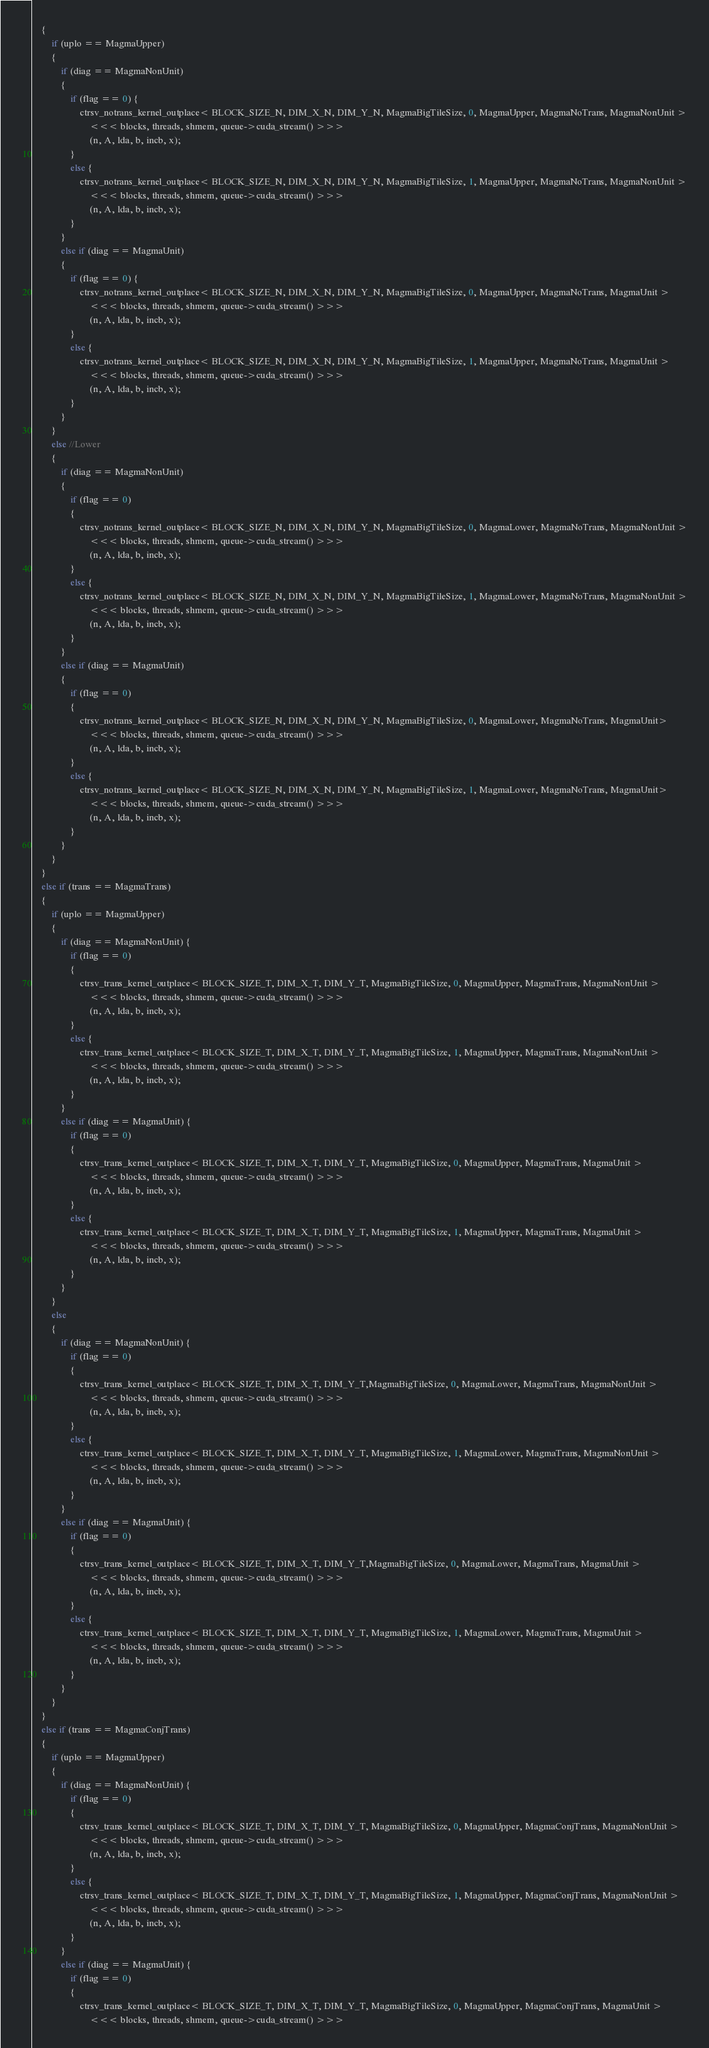Convert code to text. <code><loc_0><loc_0><loc_500><loc_500><_Cuda_>    {
        if (uplo == MagmaUpper)
        {
            if (diag == MagmaNonUnit)
            {
                if (flag == 0) {
                    ctrsv_notrans_kernel_outplace< BLOCK_SIZE_N, DIM_X_N, DIM_Y_N, MagmaBigTileSize, 0, MagmaUpper, MagmaNoTrans, MagmaNonUnit >
                        <<< blocks, threads, shmem, queue->cuda_stream() >>>
                        (n, A, lda, b, incb, x);
                }
                else {
                    ctrsv_notrans_kernel_outplace< BLOCK_SIZE_N, DIM_X_N, DIM_Y_N, MagmaBigTileSize, 1, MagmaUpper, MagmaNoTrans, MagmaNonUnit >
                        <<< blocks, threads, shmem, queue->cuda_stream() >>>
                        (n, A, lda, b, incb, x);
                }
            }
            else if (diag == MagmaUnit)
            {
                if (flag == 0) {
                    ctrsv_notrans_kernel_outplace< BLOCK_SIZE_N, DIM_X_N, DIM_Y_N, MagmaBigTileSize, 0, MagmaUpper, MagmaNoTrans, MagmaUnit >
                        <<< blocks, threads, shmem, queue->cuda_stream() >>>
                        (n, A, lda, b, incb, x);
                }
                else {
                    ctrsv_notrans_kernel_outplace< BLOCK_SIZE_N, DIM_X_N, DIM_Y_N, MagmaBigTileSize, 1, MagmaUpper, MagmaNoTrans, MagmaUnit >
                        <<< blocks, threads, shmem, queue->cuda_stream() >>>
                        (n, A, lda, b, incb, x);
                }
            }
        }
        else //Lower
        {
            if (diag == MagmaNonUnit)
            {
                if (flag == 0)
                {
                    ctrsv_notrans_kernel_outplace< BLOCK_SIZE_N, DIM_X_N, DIM_Y_N, MagmaBigTileSize, 0, MagmaLower, MagmaNoTrans, MagmaNonUnit >
                        <<< blocks, threads, shmem, queue->cuda_stream() >>>
                        (n, A, lda, b, incb, x);
                }
                else {
                    ctrsv_notrans_kernel_outplace< BLOCK_SIZE_N, DIM_X_N, DIM_Y_N, MagmaBigTileSize, 1, MagmaLower, MagmaNoTrans, MagmaNonUnit >
                        <<< blocks, threads, shmem, queue->cuda_stream() >>>
                        (n, A, lda, b, incb, x);
                }
            }
            else if (diag == MagmaUnit)
            {
                if (flag == 0)
                {
                    ctrsv_notrans_kernel_outplace< BLOCK_SIZE_N, DIM_X_N, DIM_Y_N, MagmaBigTileSize, 0, MagmaLower, MagmaNoTrans, MagmaUnit>
                        <<< blocks, threads, shmem, queue->cuda_stream() >>>
                        (n, A, lda, b, incb, x);
                }
                else {
                    ctrsv_notrans_kernel_outplace< BLOCK_SIZE_N, DIM_X_N, DIM_Y_N, MagmaBigTileSize, 1, MagmaLower, MagmaNoTrans, MagmaUnit>
                        <<< blocks, threads, shmem, queue->cuda_stream() >>>
                        (n, A, lda, b, incb, x);
                }
            }
        }
    }
    else if (trans == MagmaTrans)
    {
        if (uplo == MagmaUpper)
        {
            if (diag == MagmaNonUnit) {
                if (flag == 0)
                {
                    ctrsv_trans_kernel_outplace< BLOCK_SIZE_T, DIM_X_T, DIM_Y_T, MagmaBigTileSize, 0, MagmaUpper, MagmaTrans, MagmaNonUnit >
                        <<< blocks, threads, shmem, queue->cuda_stream() >>>
                        (n, A, lda, b, incb, x);
                }
                else {
                    ctrsv_trans_kernel_outplace< BLOCK_SIZE_T, DIM_X_T, DIM_Y_T, MagmaBigTileSize, 1, MagmaUpper, MagmaTrans, MagmaNonUnit >
                        <<< blocks, threads, shmem, queue->cuda_stream() >>>
                        (n, A, lda, b, incb, x);
                }
            }
            else if (diag == MagmaUnit) {
                if (flag == 0)
                {
                    ctrsv_trans_kernel_outplace< BLOCK_SIZE_T, DIM_X_T, DIM_Y_T, MagmaBigTileSize, 0, MagmaUpper, MagmaTrans, MagmaUnit >
                        <<< blocks, threads, shmem, queue->cuda_stream() >>>
                        (n, A, lda, b, incb, x);
                }
                else {
                    ctrsv_trans_kernel_outplace< BLOCK_SIZE_T, DIM_X_T, DIM_Y_T, MagmaBigTileSize, 1, MagmaUpper, MagmaTrans, MagmaUnit >
                        <<< blocks, threads, shmem, queue->cuda_stream() >>>
                        (n, A, lda, b, incb, x);
                }
            }
        }
        else
        {
            if (diag == MagmaNonUnit) {
                if (flag == 0)
                {
                    ctrsv_trans_kernel_outplace< BLOCK_SIZE_T, DIM_X_T, DIM_Y_T,MagmaBigTileSize, 0, MagmaLower, MagmaTrans, MagmaNonUnit >
                        <<< blocks, threads, shmem, queue->cuda_stream() >>>
                        (n, A, lda, b, incb, x);
                }
                else {
                    ctrsv_trans_kernel_outplace< BLOCK_SIZE_T, DIM_X_T, DIM_Y_T, MagmaBigTileSize, 1, MagmaLower, MagmaTrans, MagmaNonUnit >
                        <<< blocks, threads, shmem, queue->cuda_stream() >>>
                        (n, A, lda, b, incb, x);
                }
            }
            else if (diag == MagmaUnit) {
                if (flag == 0)
                {
                    ctrsv_trans_kernel_outplace< BLOCK_SIZE_T, DIM_X_T, DIM_Y_T,MagmaBigTileSize, 0, MagmaLower, MagmaTrans, MagmaUnit >
                        <<< blocks, threads, shmem, queue->cuda_stream() >>>
                        (n, A, lda, b, incb, x);
                }
                else {
                    ctrsv_trans_kernel_outplace< BLOCK_SIZE_T, DIM_X_T, DIM_Y_T, MagmaBigTileSize, 1, MagmaLower, MagmaTrans, MagmaUnit >
                        <<< blocks, threads, shmem, queue->cuda_stream() >>>
                        (n, A, lda, b, incb, x);
                }
            }
        }
    }
    else if (trans == MagmaConjTrans)
    {
        if (uplo == MagmaUpper)
        {
            if (diag == MagmaNonUnit) {
                if (flag == 0)
                {
                    ctrsv_trans_kernel_outplace< BLOCK_SIZE_T, DIM_X_T, DIM_Y_T, MagmaBigTileSize, 0, MagmaUpper, MagmaConjTrans, MagmaNonUnit >
                        <<< blocks, threads, shmem, queue->cuda_stream() >>>
                        (n, A, lda, b, incb, x);
                }
                else {
                    ctrsv_trans_kernel_outplace< BLOCK_SIZE_T, DIM_X_T, DIM_Y_T, MagmaBigTileSize, 1, MagmaUpper, MagmaConjTrans, MagmaNonUnit >
                        <<< blocks, threads, shmem, queue->cuda_stream() >>>
                        (n, A, lda, b, incb, x);
                }
            }
            else if (diag == MagmaUnit) {
                if (flag == 0)
                {
                    ctrsv_trans_kernel_outplace< BLOCK_SIZE_T, DIM_X_T, DIM_Y_T, MagmaBigTileSize, 0, MagmaUpper, MagmaConjTrans, MagmaUnit >
                        <<< blocks, threads, shmem, queue->cuda_stream() >>></code> 